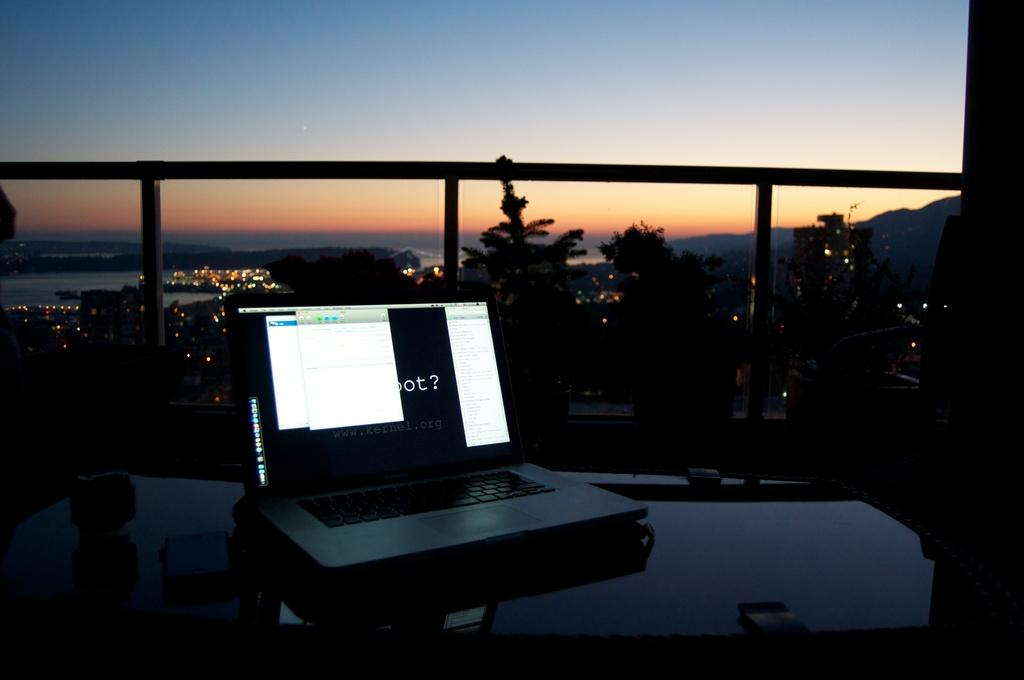<image>
Share a concise interpretation of the image provided. A laptop with some windows covering a word that ends in ot 